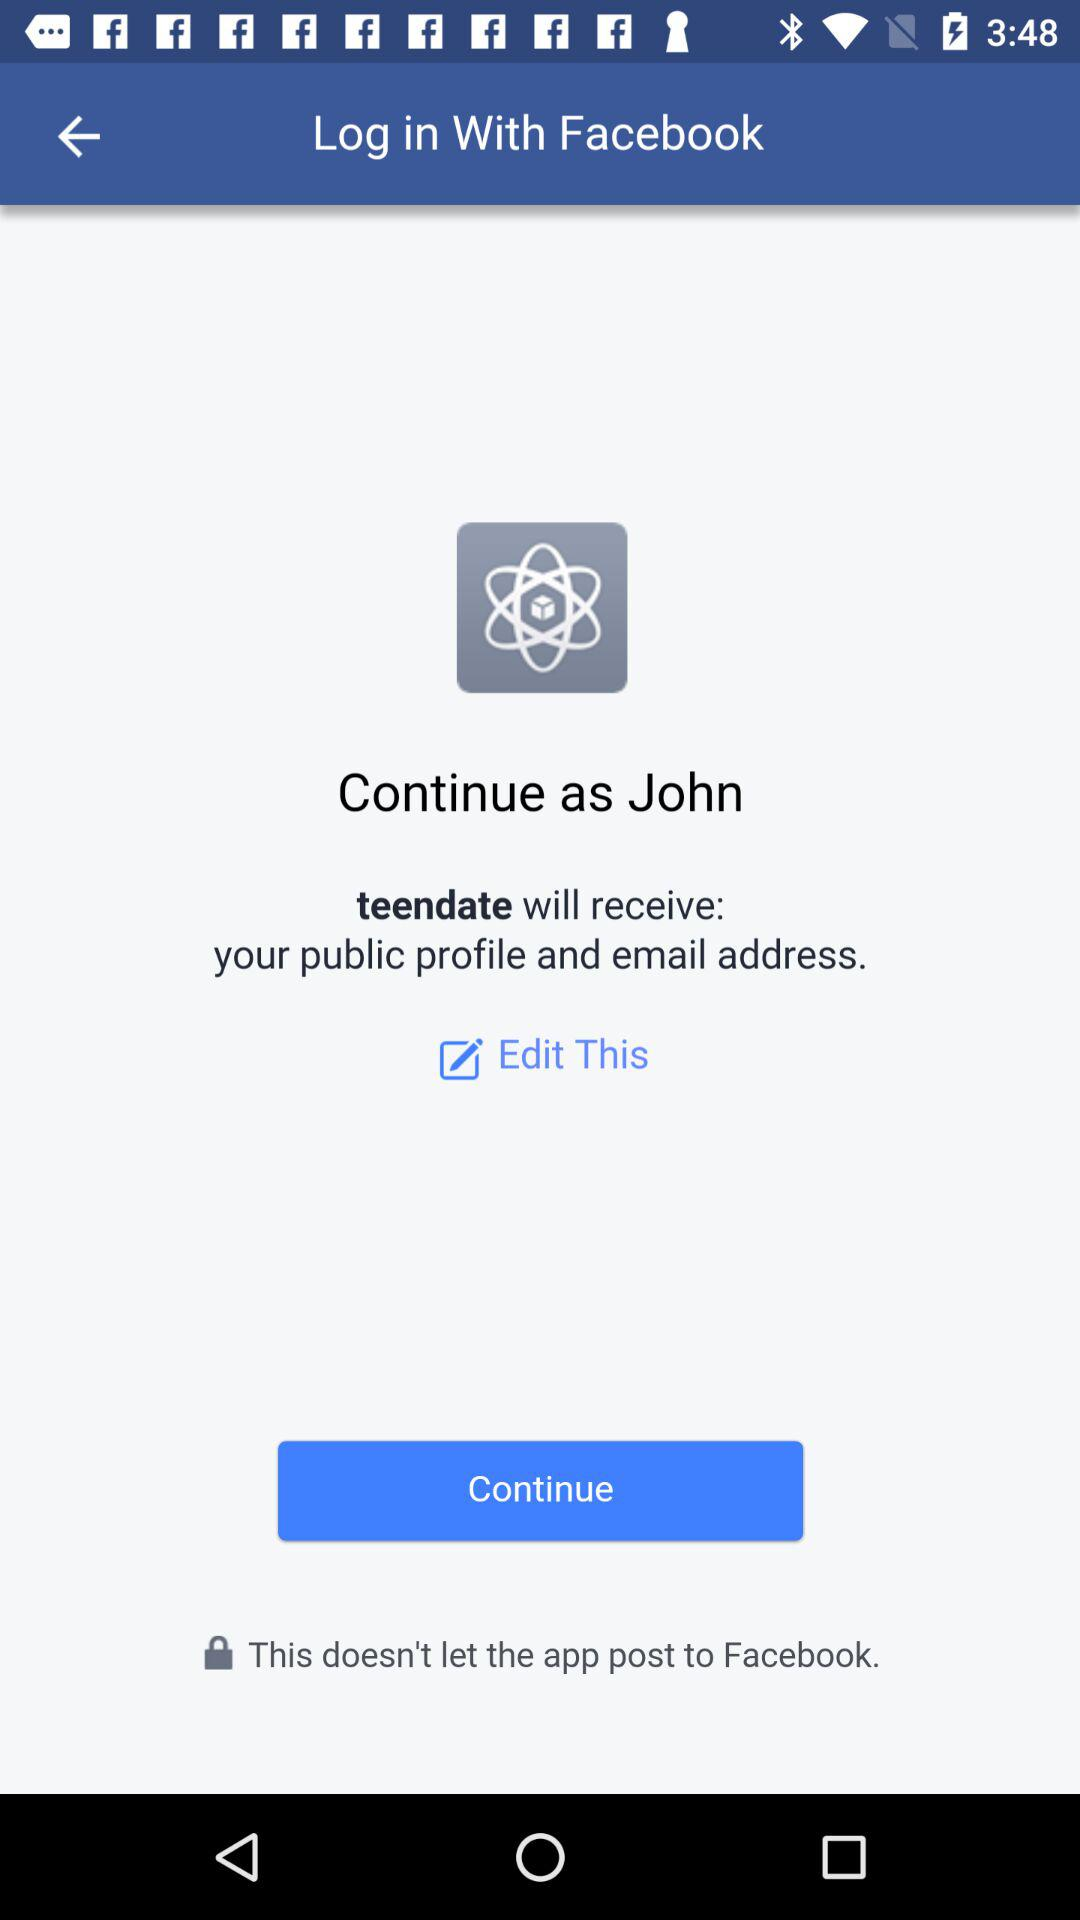Which application are we using to log in? You are using "Facebook" to log in. 